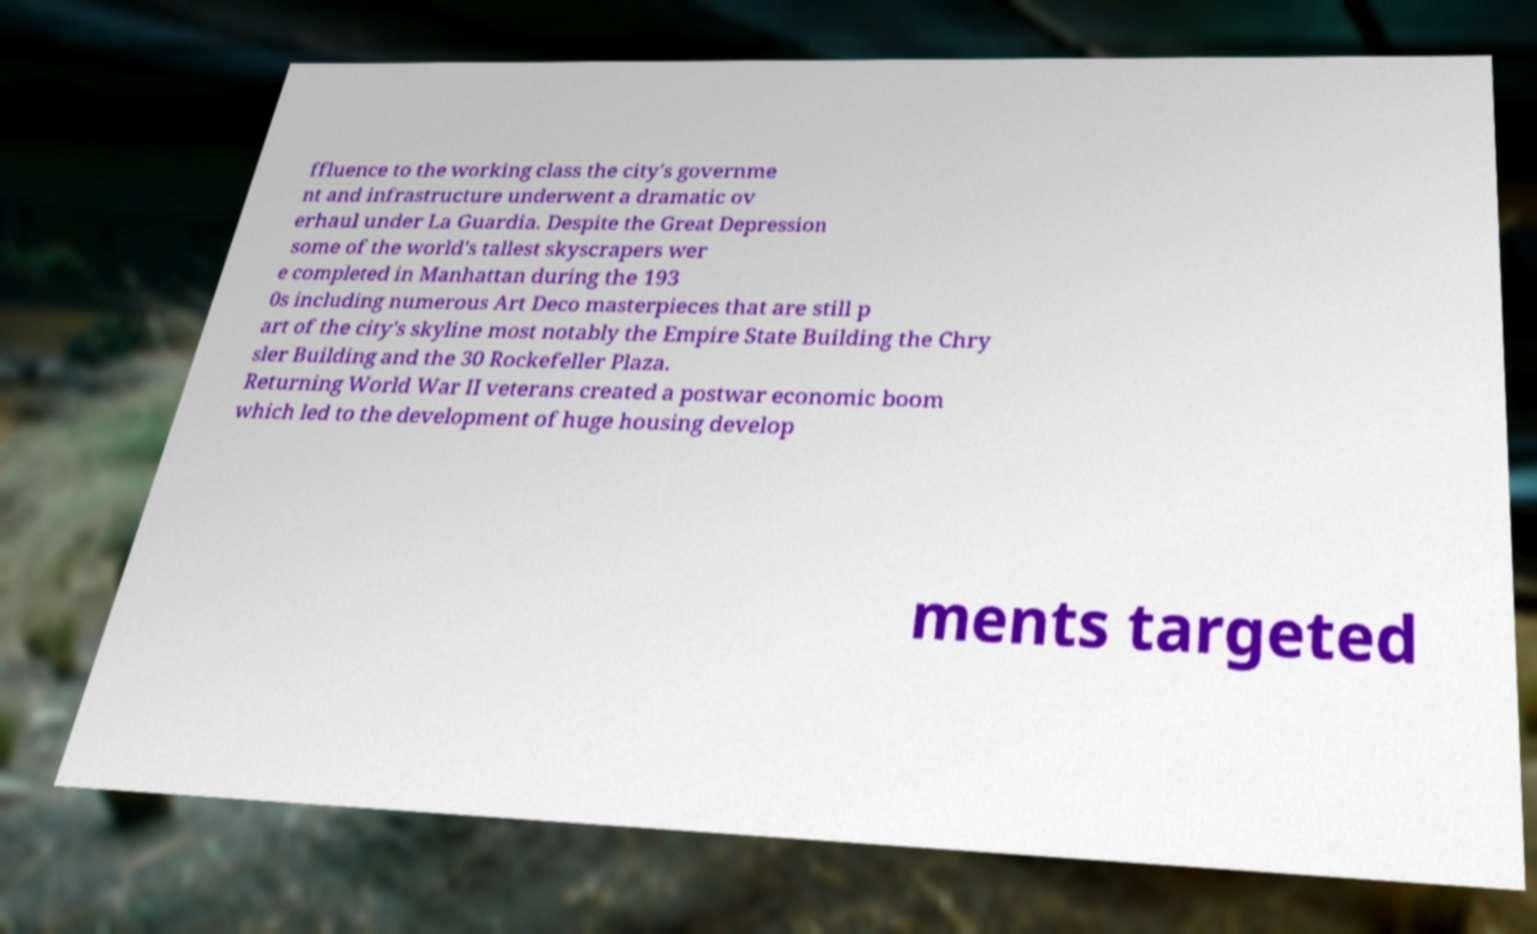Can you accurately transcribe the text from the provided image for me? ffluence to the working class the city's governme nt and infrastructure underwent a dramatic ov erhaul under La Guardia. Despite the Great Depression some of the world's tallest skyscrapers wer e completed in Manhattan during the 193 0s including numerous Art Deco masterpieces that are still p art of the city's skyline most notably the Empire State Building the Chry sler Building and the 30 Rockefeller Plaza. Returning World War II veterans created a postwar economic boom which led to the development of huge housing develop ments targeted 